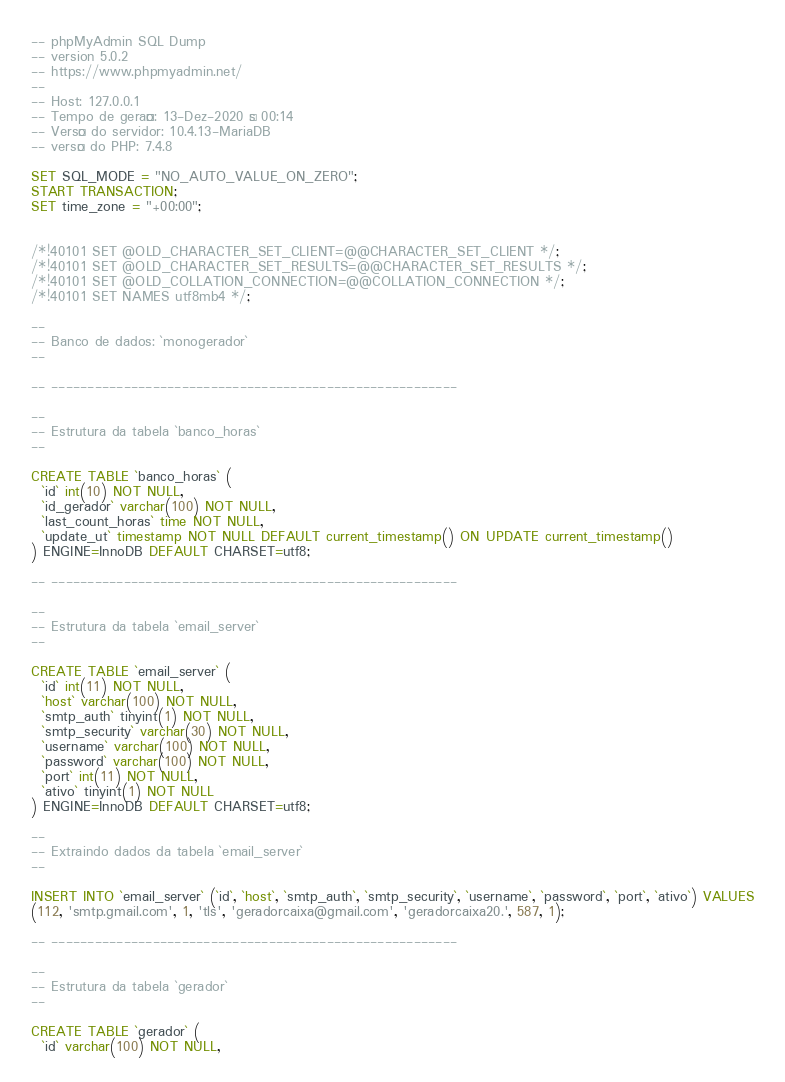<code> <loc_0><loc_0><loc_500><loc_500><_SQL_>-- phpMyAdmin SQL Dump
-- version 5.0.2
-- https://www.phpmyadmin.net/
--
-- Host: 127.0.0.1
-- Tempo de geração: 13-Dez-2020 às 00:14
-- Versão do servidor: 10.4.13-MariaDB
-- versão do PHP: 7.4.8

SET SQL_MODE = "NO_AUTO_VALUE_ON_ZERO";
START TRANSACTION;
SET time_zone = "+00:00";


/*!40101 SET @OLD_CHARACTER_SET_CLIENT=@@CHARACTER_SET_CLIENT */;
/*!40101 SET @OLD_CHARACTER_SET_RESULTS=@@CHARACTER_SET_RESULTS */;
/*!40101 SET @OLD_COLLATION_CONNECTION=@@COLLATION_CONNECTION */;
/*!40101 SET NAMES utf8mb4 */;

--
-- Banco de dados: `monogerador`
--

-- --------------------------------------------------------

--
-- Estrutura da tabela `banco_horas`
--

CREATE TABLE `banco_horas` (
  `id` int(10) NOT NULL,
  `id_gerador` varchar(100) NOT NULL,
  `last_count_horas` time NOT NULL,
  `update_ut` timestamp NOT NULL DEFAULT current_timestamp() ON UPDATE current_timestamp()
) ENGINE=InnoDB DEFAULT CHARSET=utf8;

-- --------------------------------------------------------

--
-- Estrutura da tabela `email_server`
--

CREATE TABLE `email_server` (
  `id` int(11) NOT NULL,
  `host` varchar(100) NOT NULL,
  `smtp_auth` tinyint(1) NOT NULL,
  `smtp_security` varchar(30) NOT NULL,
  `username` varchar(100) NOT NULL,
  `password` varchar(100) NOT NULL,
  `port` int(11) NOT NULL,
  `ativo` tinyint(1) NOT NULL
) ENGINE=InnoDB DEFAULT CHARSET=utf8;

--
-- Extraindo dados da tabela `email_server`
--

INSERT INTO `email_server` (`id`, `host`, `smtp_auth`, `smtp_security`, `username`, `password`, `port`, `ativo`) VALUES
(112, 'smtp.gmail.com', 1, 'tls', 'geradorcaixa@gmail.com', 'geradorcaixa20.', 587, 1);

-- --------------------------------------------------------

--
-- Estrutura da tabela `gerador`
--

CREATE TABLE `gerador` (
  `id` varchar(100) NOT NULL,</code> 